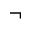Convert formula to latex. <formula><loc_0><loc_0><loc_500><loc_500>\neg</formula> 